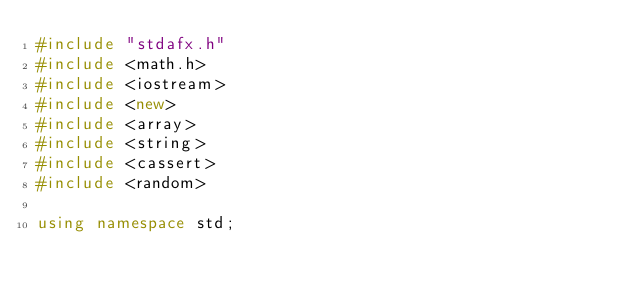Convert code to text. <code><loc_0><loc_0><loc_500><loc_500><_C++_>#include "stdafx.h"
#include <math.h>
#include <iostream>
#include <new>
#include <array>
#include <string>
#include <cassert>
#include <random>

using namespace std;</code> 